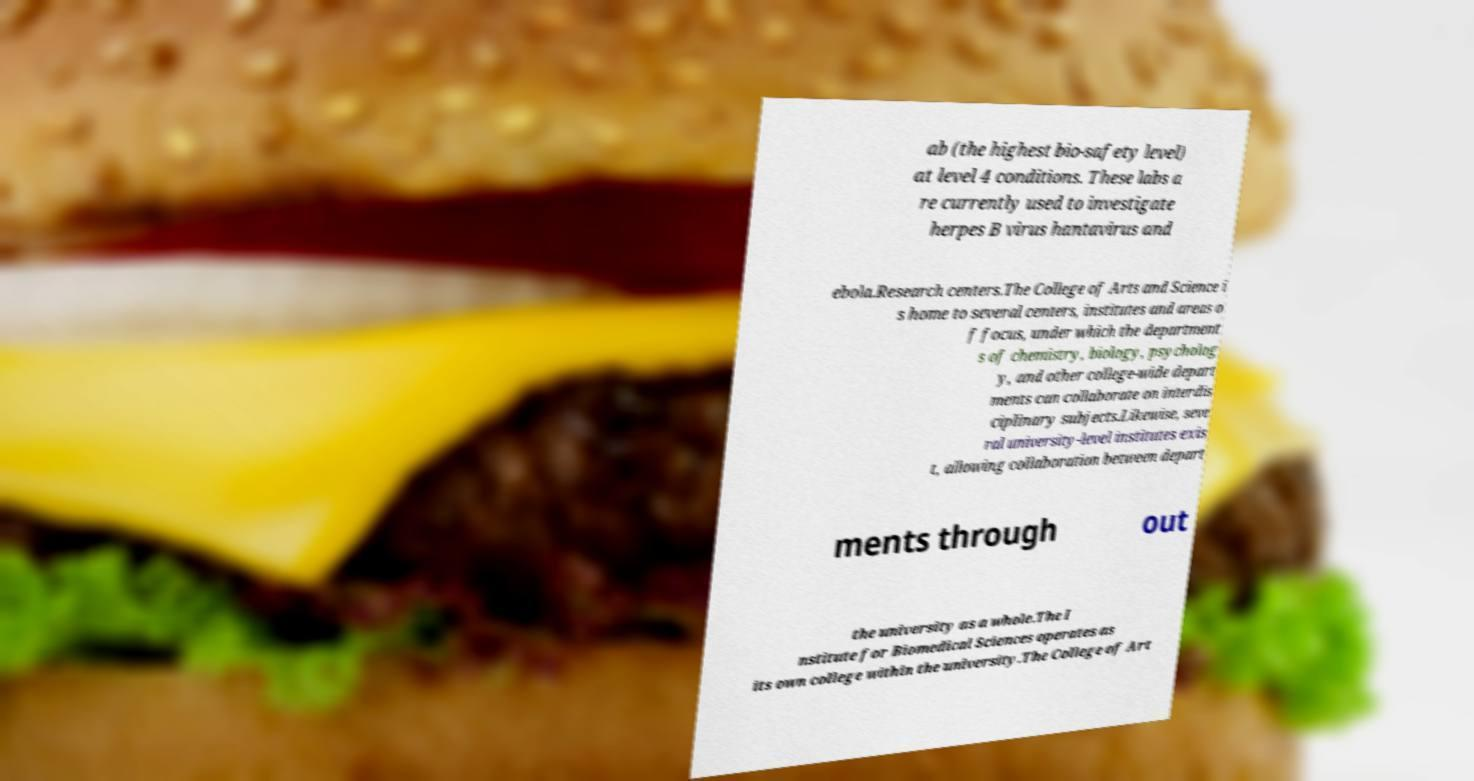What messages or text are displayed in this image? I need them in a readable, typed format. ab (the highest bio-safety level) at level 4 conditions. These labs a re currently used to investigate herpes B virus hantavirus and ebola.Research centers.The College of Arts and Science i s home to several centers, institutes and areas o f focus, under which the department s of chemistry, biology, psycholog y, and other college-wide depart ments can collaborate on interdis ciplinary subjects.Likewise, seve ral university-level institutes exis t, allowing collaboration between depart ments through out the university as a whole.The I nstitute for Biomedical Sciences operates as its own college within the university.The College of Art 